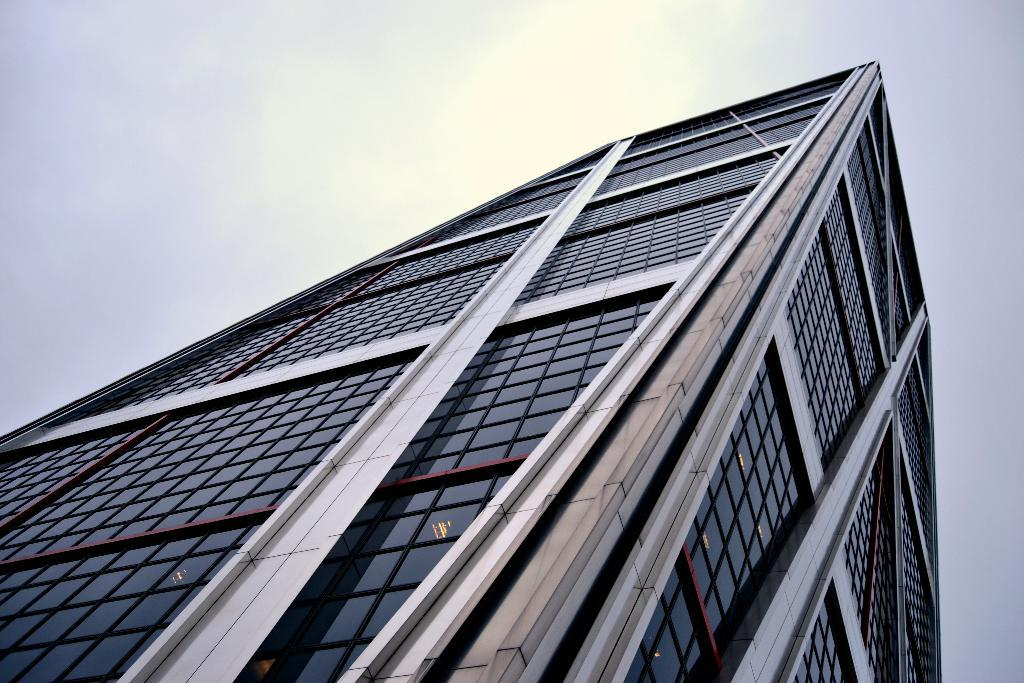What type of structure is present in the image? There is a building in the image. What feature can be seen on the building? There are glass doors in the image. What can be seen in the sky in the background of the image? The sun is visible in the sky in the background of the image. How many passengers are waiting outside the building in the image? There is no indication of passengers or any waiting individuals in the image. 